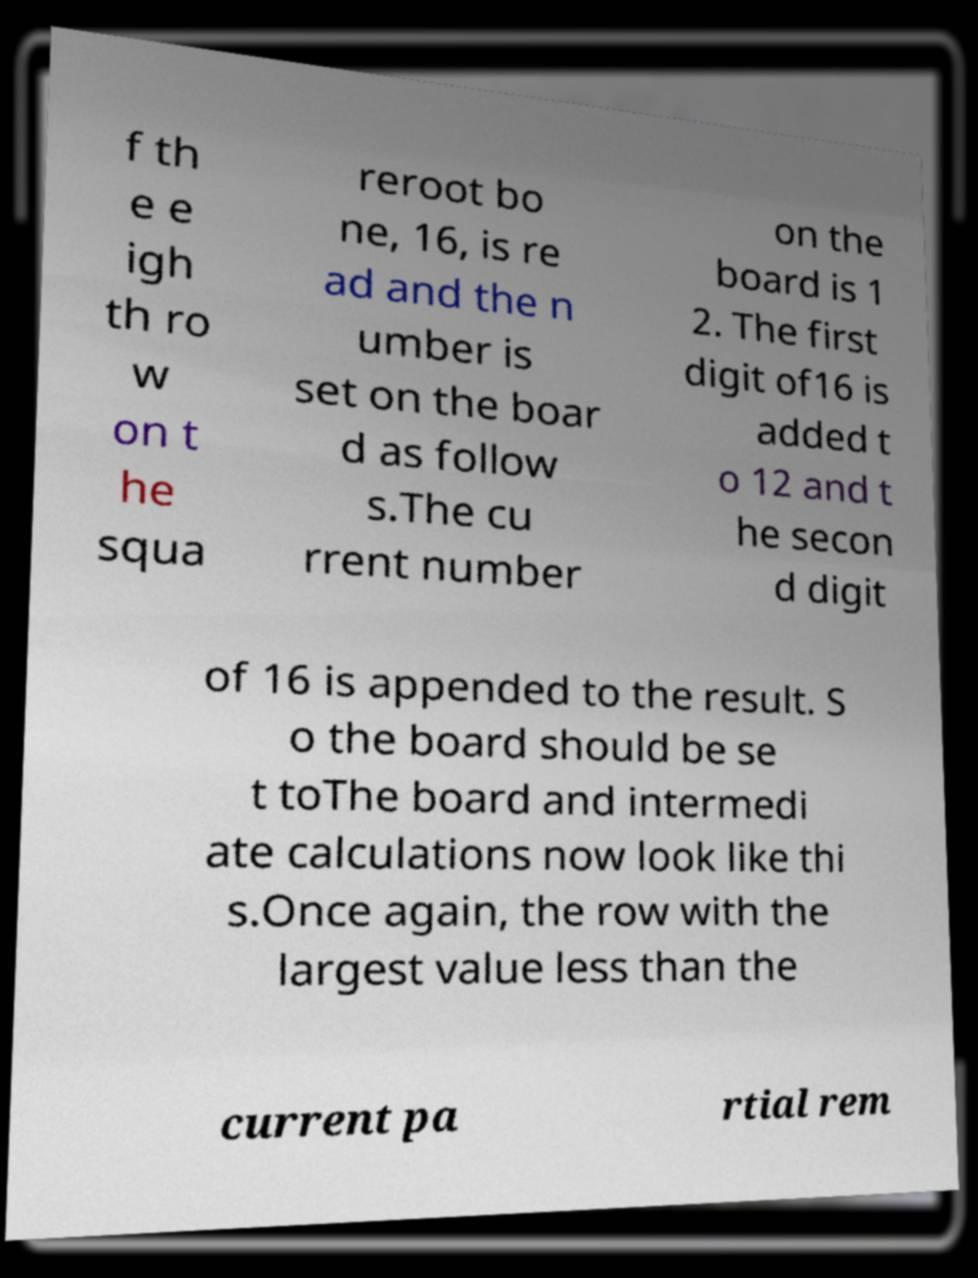Please identify and transcribe the text found in this image. f th e e igh th ro w on t he squa reroot bo ne, 16, is re ad and the n umber is set on the boar d as follow s.The cu rrent number on the board is 1 2. The first digit of16 is added t o 12 and t he secon d digit of 16 is appended to the result. S o the board should be se t toThe board and intermedi ate calculations now look like thi s.Once again, the row with the largest value less than the current pa rtial rem 